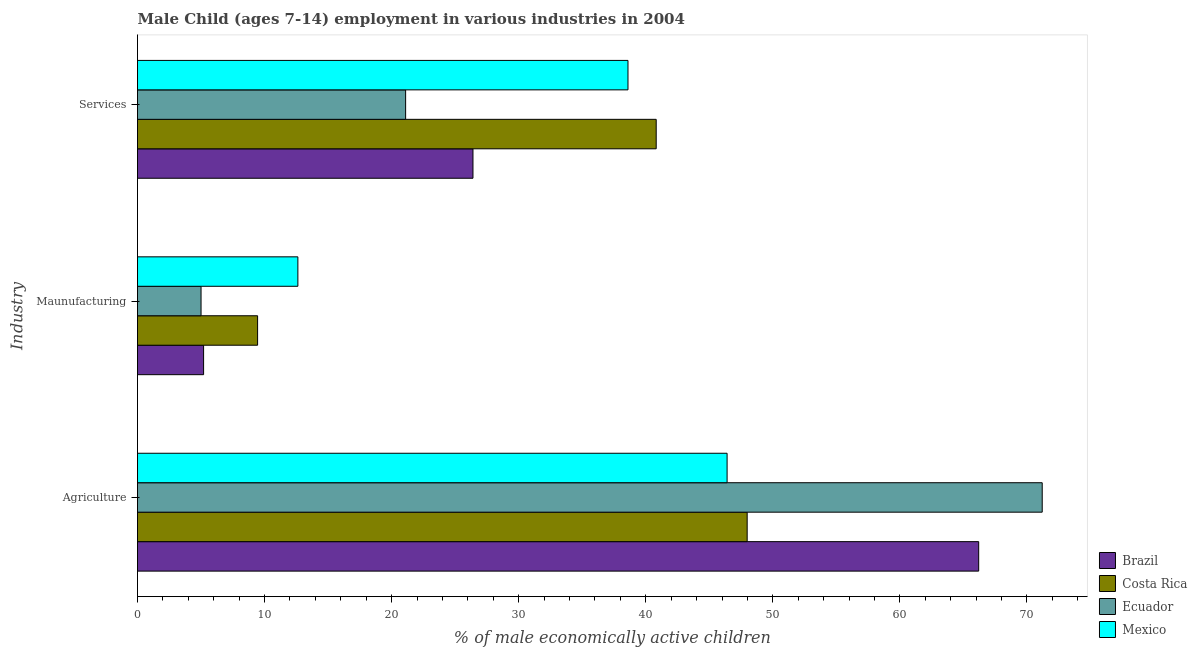How many different coloured bars are there?
Keep it short and to the point. 4. Are the number of bars per tick equal to the number of legend labels?
Ensure brevity in your answer.  Yes. Are the number of bars on each tick of the Y-axis equal?
Provide a succinct answer. Yes. What is the label of the 2nd group of bars from the top?
Provide a succinct answer. Maunufacturing. What is the percentage of economically active children in manufacturing in Mexico?
Make the answer very short. 12.62. Across all countries, what is the maximum percentage of economically active children in agriculture?
Keep it short and to the point. 71.2. Across all countries, what is the minimum percentage of economically active children in agriculture?
Provide a short and direct response. 46.4. In which country was the percentage of economically active children in agriculture maximum?
Ensure brevity in your answer.  Ecuador. In which country was the percentage of economically active children in manufacturing minimum?
Make the answer very short. Ecuador. What is the total percentage of economically active children in manufacturing in the graph?
Your answer should be very brief. 32.27. What is the difference between the percentage of economically active children in agriculture in Costa Rica and that in Brazil?
Offer a terse response. -18.22. What is the difference between the percentage of economically active children in agriculture in Costa Rica and the percentage of economically active children in manufacturing in Mexico?
Offer a very short reply. 35.36. What is the average percentage of economically active children in agriculture per country?
Provide a succinct answer. 57.95. What is the difference between the percentage of economically active children in agriculture and percentage of economically active children in manufacturing in Mexico?
Offer a terse response. 33.78. What is the ratio of the percentage of economically active children in services in Ecuador to that in Costa Rica?
Your answer should be very brief. 0.52. Is the percentage of economically active children in agriculture in Brazil less than that in Costa Rica?
Provide a succinct answer. No. What is the difference between the highest and the second highest percentage of economically active children in manufacturing?
Your response must be concise. 3.17. What is the difference between the highest and the lowest percentage of economically active children in manufacturing?
Offer a terse response. 7.62. In how many countries, is the percentage of economically active children in manufacturing greater than the average percentage of economically active children in manufacturing taken over all countries?
Keep it short and to the point. 2. Is the sum of the percentage of economically active children in manufacturing in Brazil and Ecuador greater than the maximum percentage of economically active children in agriculture across all countries?
Provide a short and direct response. No. What does the 1st bar from the top in Agriculture represents?
Your response must be concise. Mexico. What does the 2nd bar from the bottom in Services represents?
Your answer should be very brief. Costa Rica. Is it the case that in every country, the sum of the percentage of economically active children in agriculture and percentage of economically active children in manufacturing is greater than the percentage of economically active children in services?
Your answer should be compact. Yes. Are all the bars in the graph horizontal?
Your answer should be compact. Yes. How many countries are there in the graph?
Your answer should be compact. 4. What is the difference between two consecutive major ticks on the X-axis?
Offer a very short reply. 10. Are the values on the major ticks of X-axis written in scientific E-notation?
Keep it short and to the point. No. How are the legend labels stacked?
Make the answer very short. Vertical. What is the title of the graph?
Your answer should be compact. Male Child (ages 7-14) employment in various industries in 2004. Does "Malta" appear as one of the legend labels in the graph?
Make the answer very short. No. What is the label or title of the X-axis?
Your response must be concise. % of male economically active children. What is the label or title of the Y-axis?
Offer a terse response. Industry. What is the % of male economically active children in Brazil in Agriculture?
Provide a succinct answer. 66.2. What is the % of male economically active children in Costa Rica in Agriculture?
Your answer should be very brief. 47.98. What is the % of male economically active children in Ecuador in Agriculture?
Offer a very short reply. 71.2. What is the % of male economically active children of Mexico in Agriculture?
Offer a very short reply. 46.4. What is the % of male economically active children in Brazil in Maunufacturing?
Offer a terse response. 5.2. What is the % of male economically active children of Costa Rica in Maunufacturing?
Provide a succinct answer. 9.45. What is the % of male economically active children of Mexico in Maunufacturing?
Ensure brevity in your answer.  12.62. What is the % of male economically active children in Brazil in Services?
Provide a succinct answer. 26.4. What is the % of male economically active children of Costa Rica in Services?
Your answer should be compact. 40.82. What is the % of male economically active children in Ecuador in Services?
Ensure brevity in your answer.  21.1. What is the % of male economically active children in Mexico in Services?
Provide a short and direct response. 38.6. Across all Industry, what is the maximum % of male economically active children of Brazil?
Your answer should be very brief. 66.2. Across all Industry, what is the maximum % of male economically active children of Costa Rica?
Keep it short and to the point. 47.98. Across all Industry, what is the maximum % of male economically active children in Ecuador?
Give a very brief answer. 71.2. Across all Industry, what is the maximum % of male economically active children of Mexico?
Your answer should be very brief. 46.4. Across all Industry, what is the minimum % of male economically active children in Brazil?
Your answer should be very brief. 5.2. Across all Industry, what is the minimum % of male economically active children of Costa Rica?
Your response must be concise. 9.45. Across all Industry, what is the minimum % of male economically active children of Ecuador?
Provide a succinct answer. 5. Across all Industry, what is the minimum % of male economically active children in Mexico?
Give a very brief answer. 12.62. What is the total % of male economically active children in Brazil in the graph?
Give a very brief answer. 97.8. What is the total % of male economically active children of Costa Rica in the graph?
Provide a succinct answer. 98.25. What is the total % of male economically active children in Ecuador in the graph?
Give a very brief answer. 97.3. What is the total % of male economically active children of Mexico in the graph?
Your response must be concise. 97.62. What is the difference between the % of male economically active children of Costa Rica in Agriculture and that in Maunufacturing?
Offer a very short reply. 38.53. What is the difference between the % of male economically active children of Ecuador in Agriculture and that in Maunufacturing?
Provide a succinct answer. 66.2. What is the difference between the % of male economically active children of Mexico in Agriculture and that in Maunufacturing?
Offer a very short reply. 33.78. What is the difference between the % of male economically active children in Brazil in Agriculture and that in Services?
Offer a terse response. 39.8. What is the difference between the % of male economically active children of Costa Rica in Agriculture and that in Services?
Provide a short and direct response. 7.16. What is the difference between the % of male economically active children in Ecuador in Agriculture and that in Services?
Offer a terse response. 50.1. What is the difference between the % of male economically active children of Brazil in Maunufacturing and that in Services?
Offer a terse response. -21.2. What is the difference between the % of male economically active children of Costa Rica in Maunufacturing and that in Services?
Keep it short and to the point. -31.37. What is the difference between the % of male economically active children of Ecuador in Maunufacturing and that in Services?
Offer a terse response. -16.1. What is the difference between the % of male economically active children of Mexico in Maunufacturing and that in Services?
Your answer should be compact. -25.98. What is the difference between the % of male economically active children of Brazil in Agriculture and the % of male economically active children of Costa Rica in Maunufacturing?
Provide a succinct answer. 56.75. What is the difference between the % of male economically active children of Brazil in Agriculture and the % of male economically active children of Ecuador in Maunufacturing?
Provide a succinct answer. 61.2. What is the difference between the % of male economically active children in Brazil in Agriculture and the % of male economically active children in Mexico in Maunufacturing?
Give a very brief answer. 53.58. What is the difference between the % of male economically active children of Costa Rica in Agriculture and the % of male economically active children of Ecuador in Maunufacturing?
Your response must be concise. 42.98. What is the difference between the % of male economically active children in Costa Rica in Agriculture and the % of male economically active children in Mexico in Maunufacturing?
Your answer should be very brief. 35.36. What is the difference between the % of male economically active children of Ecuador in Agriculture and the % of male economically active children of Mexico in Maunufacturing?
Provide a succinct answer. 58.58. What is the difference between the % of male economically active children of Brazil in Agriculture and the % of male economically active children of Costa Rica in Services?
Make the answer very short. 25.38. What is the difference between the % of male economically active children in Brazil in Agriculture and the % of male economically active children in Ecuador in Services?
Offer a very short reply. 45.1. What is the difference between the % of male economically active children of Brazil in Agriculture and the % of male economically active children of Mexico in Services?
Keep it short and to the point. 27.6. What is the difference between the % of male economically active children of Costa Rica in Agriculture and the % of male economically active children of Ecuador in Services?
Provide a succinct answer. 26.88. What is the difference between the % of male economically active children of Costa Rica in Agriculture and the % of male economically active children of Mexico in Services?
Offer a terse response. 9.38. What is the difference between the % of male economically active children in Ecuador in Agriculture and the % of male economically active children in Mexico in Services?
Make the answer very short. 32.6. What is the difference between the % of male economically active children of Brazil in Maunufacturing and the % of male economically active children of Costa Rica in Services?
Your answer should be compact. -35.62. What is the difference between the % of male economically active children in Brazil in Maunufacturing and the % of male economically active children in Ecuador in Services?
Ensure brevity in your answer.  -15.9. What is the difference between the % of male economically active children in Brazil in Maunufacturing and the % of male economically active children in Mexico in Services?
Offer a very short reply. -33.4. What is the difference between the % of male economically active children of Costa Rica in Maunufacturing and the % of male economically active children of Ecuador in Services?
Your answer should be very brief. -11.65. What is the difference between the % of male economically active children in Costa Rica in Maunufacturing and the % of male economically active children in Mexico in Services?
Provide a short and direct response. -29.15. What is the difference between the % of male economically active children of Ecuador in Maunufacturing and the % of male economically active children of Mexico in Services?
Your response must be concise. -33.6. What is the average % of male economically active children of Brazil per Industry?
Make the answer very short. 32.6. What is the average % of male economically active children in Costa Rica per Industry?
Provide a succinct answer. 32.75. What is the average % of male economically active children of Ecuador per Industry?
Offer a very short reply. 32.43. What is the average % of male economically active children in Mexico per Industry?
Your answer should be very brief. 32.54. What is the difference between the % of male economically active children of Brazil and % of male economically active children of Costa Rica in Agriculture?
Your response must be concise. 18.22. What is the difference between the % of male economically active children in Brazil and % of male economically active children in Ecuador in Agriculture?
Keep it short and to the point. -5. What is the difference between the % of male economically active children of Brazil and % of male economically active children of Mexico in Agriculture?
Keep it short and to the point. 19.8. What is the difference between the % of male economically active children in Costa Rica and % of male economically active children in Ecuador in Agriculture?
Give a very brief answer. -23.22. What is the difference between the % of male economically active children of Costa Rica and % of male economically active children of Mexico in Agriculture?
Offer a terse response. 1.58. What is the difference between the % of male economically active children of Ecuador and % of male economically active children of Mexico in Agriculture?
Your response must be concise. 24.8. What is the difference between the % of male economically active children of Brazil and % of male economically active children of Costa Rica in Maunufacturing?
Give a very brief answer. -4.25. What is the difference between the % of male economically active children in Brazil and % of male economically active children in Mexico in Maunufacturing?
Provide a succinct answer. -7.42. What is the difference between the % of male economically active children in Costa Rica and % of male economically active children in Ecuador in Maunufacturing?
Provide a short and direct response. 4.45. What is the difference between the % of male economically active children of Costa Rica and % of male economically active children of Mexico in Maunufacturing?
Make the answer very short. -3.17. What is the difference between the % of male economically active children of Ecuador and % of male economically active children of Mexico in Maunufacturing?
Offer a terse response. -7.62. What is the difference between the % of male economically active children of Brazil and % of male economically active children of Costa Rica in Services?
Provide a succinct answer. -14.42. What is the difference between the % of male economically active children of Brazil and % of male economically active children of Ecuador in Services?
Ensure brevity in your answer.  5.3. What is the difference between the % of male economically active children of Costa Rica and % of male economically active children of Ecuador in Services?
Provide a succinct answer. 19.72. What is the difference between the % of male economically active children in Costa Rica and % of male economically active children in Mexico in Services?
Offer a terse response. 2.22. What is the difference between the % of male economically active children in Ecuador and % of male economically active children in Mexico in Services?
Provide a short and direct response. -17.5. What is the ratio of the % of male economically active children of Brazil in Agriculture to that in Maunufacturing?
Your response must be concise. 12.73. What is the ratio of the % of male economically active children in Costa Rica in Agriculture to that in Maunufacturing?
Keep it short and to the point. 5.08. What is the ratio of the % of male economically active children of Ecuador in Agriculture to that in Maunufacturing?
Your answer should be compact. 14.24. What is the ratio of the % of male economically active children in Mexico in Agriculture to that in Maunufacturing?
Keep it short and to the point. 3.68. What is the ratio of the % of male economically active children in Brazil in Agriculture to that in Services?
Ensure brevity in your answer.  2.51. What is the ratio of the % of male economically active children of Costa Rica in Agriculture to that in Services?
Your answer should be very brief. 1.18. What is the ratio of the % of male economically active children of Ecuador in Agriculture to that in Services?
Make the answer very short. 3.37. What is the ratio of the % of male economically active children of Mexico in Agriculture to that in Services?
Provide a short and direct response. 1.2. What is the ratio of the % of male economically active children of Brazil in Maunufacturing to that in Services?
Provide a succinct answer. 0.2. What is the ratio of the % of male economically active children of Costa Rica in Maunufacturing to that in Services?
Offer a very short reply. 0.23. What is the ratio of the % of male economically active children in Ecuador in Maunufacturing to that in Services?
Provide a succinct answer. 0.24. What is the ratio of the % of male economically active children in Mexico in Maunufacturing to that in Services?
Your response must be concise. 0.33. What is the difference between the highest and the second highest % of male economically active children of Brazil?
Provide a succinct answer. 39.8. What is the difference between the highest and the second highest % of male economically active children of Costa Rica?
Provide a short and direct response. 7.16. What is the difference between the highest and the second highest % of male economically active children of Ecuador?
Make the answer very short. 50.1. What is the difference between the highest and the second highest % of male economically active children in Mexico?
Provide a succinct answer. 7.8. What is the difference between the highest and the lowest % of male economically active children of Brazil?
Give a very brief answer. 61. What is the difference between the highest and the lowest % of male economically active children of Costa Rica?
Provide a short and direct response. 38.53. What is the difference between the highest and the lowest % of male economically active children of Ecuador?
Keep it short and to the point. 66.2. What is the difference between the highest and the lowest % of male economically active children of Mexico?
Offer a terse response. 33.78. 